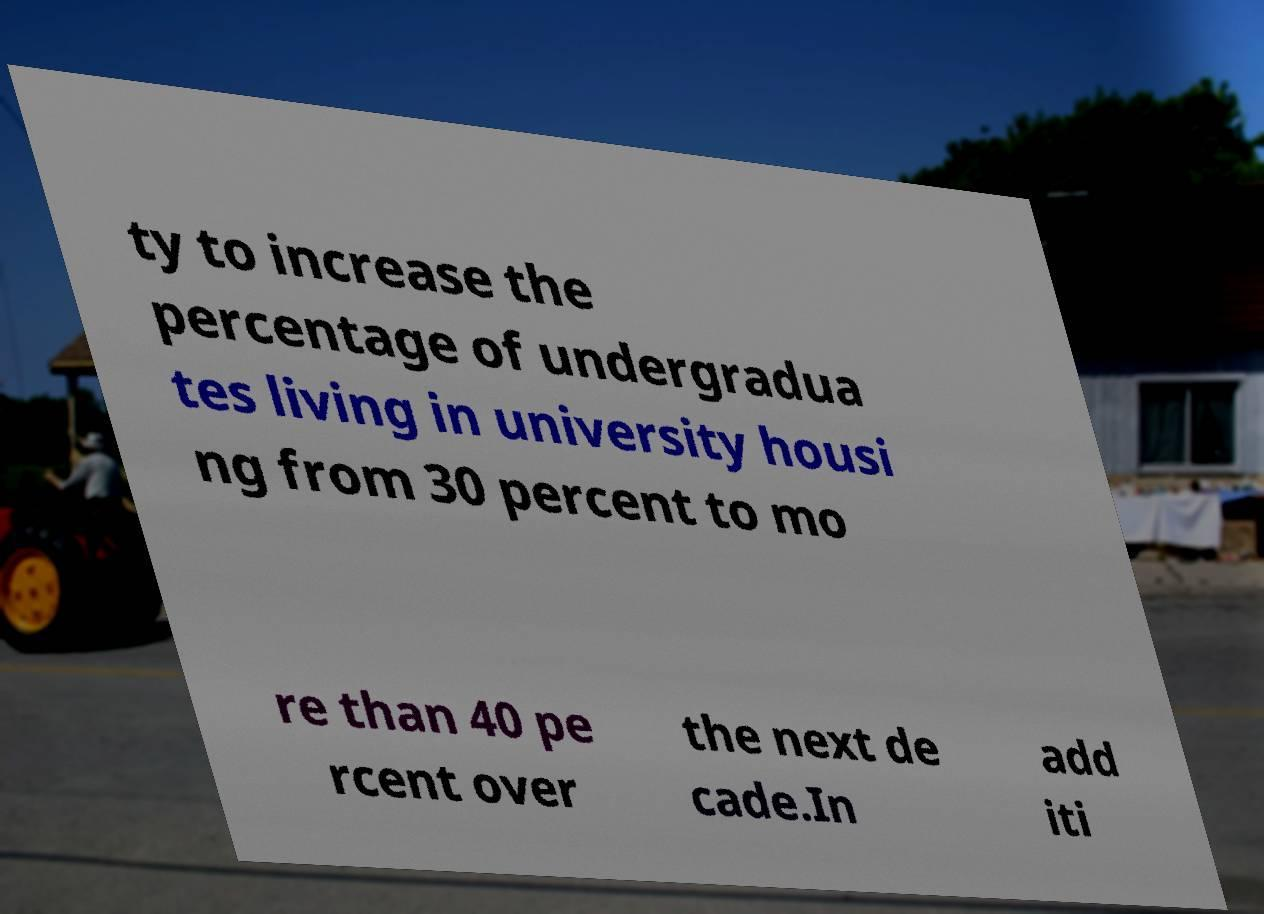Could you assist in decoding the text presented in this image and type it out clearly? ty to increase the percentage of undergradua tes living in university housi ng from 30 percent to mo re than 40 pe rcent over the next de cade.In add iti 